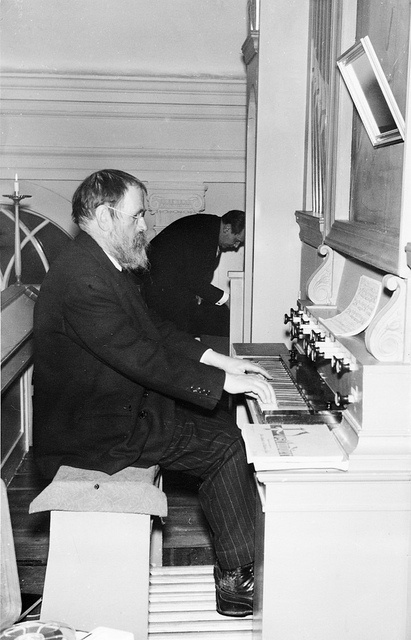Describe the objects in this image and their specific colors. I can see people in lightgray, black, gray, and darkgray tones, chair in lightgray, darkgray, gray, and black tones, and people in lightgray, black, gray, and darkgray tones in this image. 